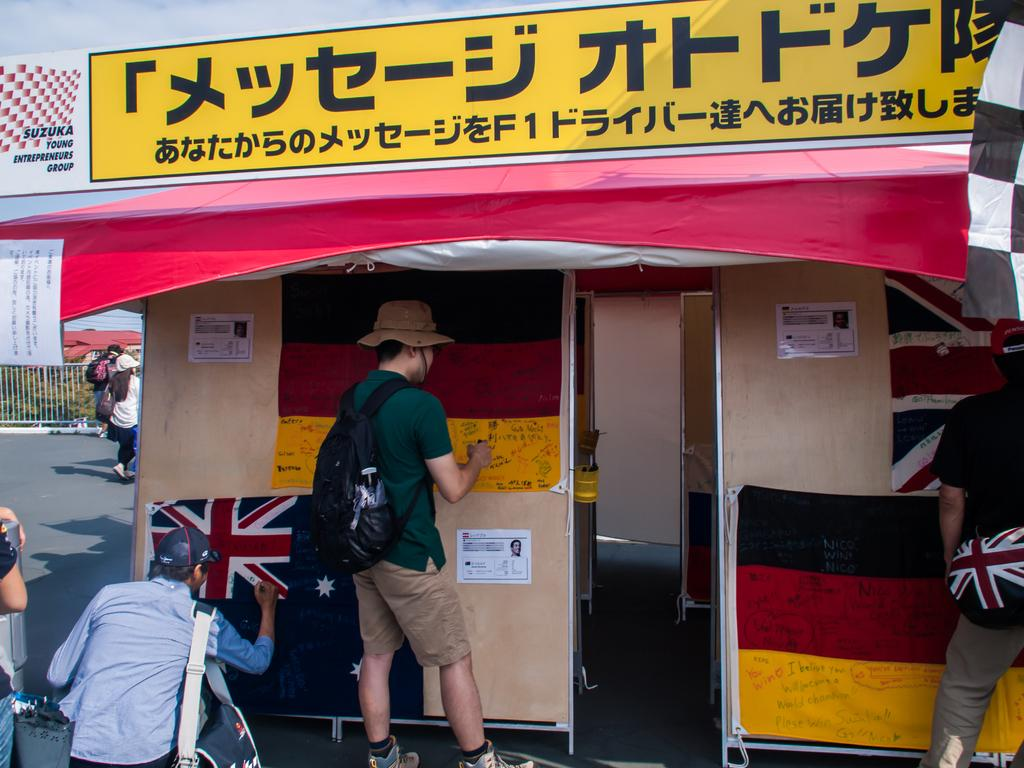Provide a one-sentence caption for the provided image. People have written Nico Win on a flag outside a building. 